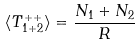Convert formula to latex. <formula><loc_0><loc_0><loc_500><loc_500>\langle T _ { 1 + 2 } ^ { + + } \rangle = \frac { N _ { 1 } + N _ { 2 } } { R }</formula> 